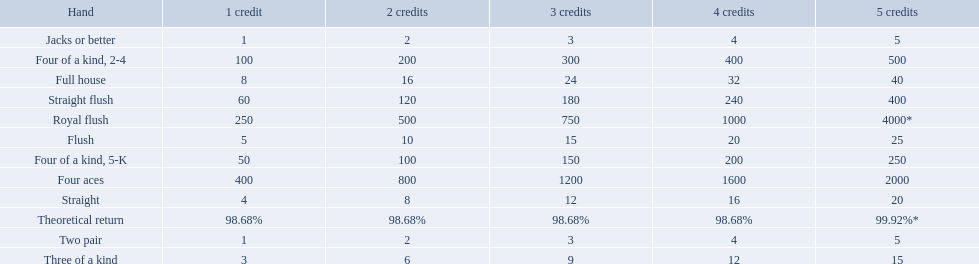What are the top 5 best types of hand for winning? Royal flush, Straight flush, Four aces, Four of a kind, 2-4, Four of a kind, 5-K. Between those 5, which of those hands are four of a kind? Four of a kind, 2-4, Four of a kind, 5-K. Of those 2 hands, which is the best kind of four of a kind for winning? Four of a kind, 2-4. 